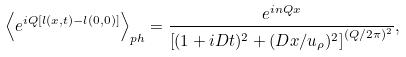<formula> <loc_0><loc_0><loc_500><loc_500>\left \langle e ^ { i Q [ l ( x , t ) - l ( 0 , 0 ) ] } \right \rangle _ { p h } = \frac { e ^ { i n Q x } } { \left [ ( 1 + i D t ) ^ { 2 } + ( D x / u _ { \rho } ) ^ { 2 } \right ] ^ { ( Q / 2 \pi ) ^ { 2 } } } ,</formula> 